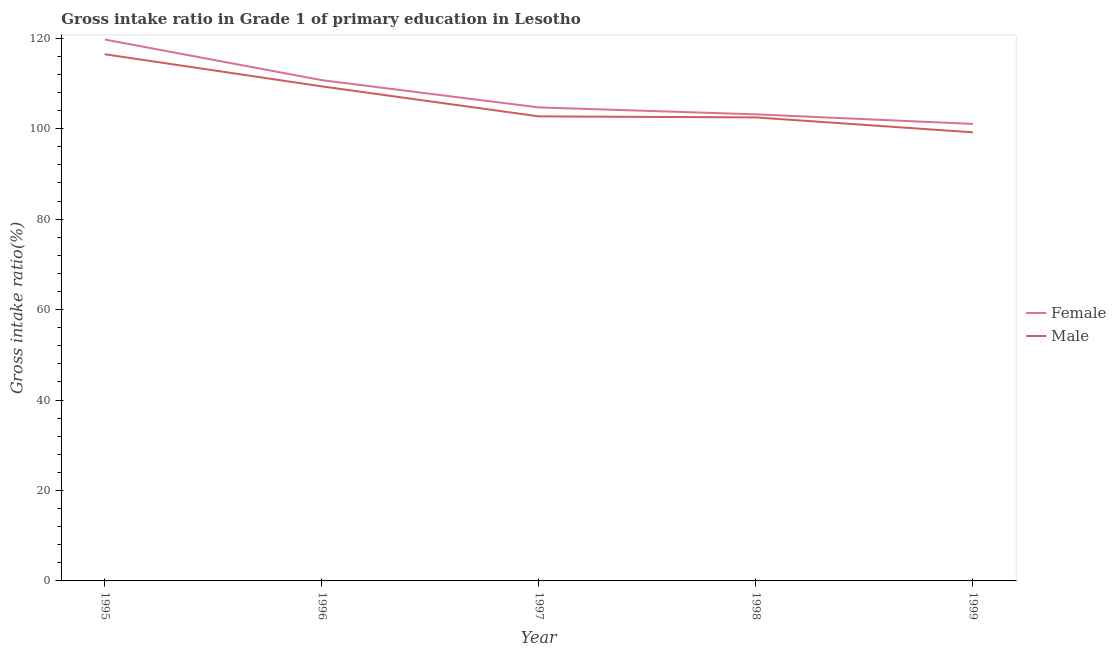How many different coloured lines are there?
Your answer should be compact. 2. Does the line corresponding to gross intake ratio(female) intersect with the line corresponding to gross intake ratio(male)?
Your answer should be compact. No. Is the number of lines equal to the number of legend labels?
Make the answer very short. Yes. What is the gross intake ratio(female) in 1997?
Make the answer very short. 104.71. Across all years, what is the maximum gross intake ratio(female)?
Give a very brief answer. 119.72. Across all years, what is the minimum gross intake ratio(male)?
Give a very brief answer. 99.2. What is the total gross intake ratio(female) in the graph?
Offer a terse response. 539.4. What is the difference between the gross intake ratio(female) in 1995 and that in 1997?
Keep it short and to the point. 15.01. What is the difference between the gross intake ratio(male) in 1996 and the gross intake ratio(female) in 1998?
Give a very brief answer. 6.19. What is the average gross intake ratio(female) per year?
Offer a very short reply. 107.88. In the year 1997, what is the difference between the gross intake ratio(female) and gross intake ratio(male)?
Your response must be concise. 1.98. What is the ratio of the gross intake ratio(male) in 1998 to that in 1999?
Your answer should be compact. 1.03. Is the gross intake ratio(male) in 1996 less than that in 1998?
Offer a terse response. No. Is the difference between the gross intake ratio(male) in 1995 and 1999 greater than the difference between the gross intake ratio(female) in 1995 and 1999?
Ensure brevity in your answer.  No. What is the difference between the highest and the second highest gross intake ratio(female)?
Your answer should be compact. 8.99. What is the difference between the highest and the lowest gross intake ratio(female)?
Provide a succinct answer. 18.67. Is the sum of the gross intake ratio(male) in 1995 and 1996 greater than the maximum gross intake ratio(female) across all years?
Offer a very short reply. Yes. Is the gross intake ratio(male) strictly greater than the gross intake ratio(female) over the years?
Offer a terse response. No. How many legend labels are there?
Your answer should be compact. 2. What is the title of the graph?
Offer a terse response. Gross intake ratio in Grade 1 of primary education in Lesotho. Does "Private consumption" appear as one of the legend labels in the graph?
Offer a terse response. No. What is the label or title of the Y-axis?
Keep it short and to the point. Gross intake ratio(%). What is the Gross intake ratio(%) of Female in 1995?
Your answer should be very brief. 119.72. What is the Gross intake ratio(%) in Male in 1995?
Your response must be concise. 116.47. What is the Gross intake ratio(%) in Female in 1996?
Your response must be concise. 110.73. What is the Gross intake ratio(%) in Male in 1996?
Your answer should be very brief. 109.36. What is the Gross intake ratio(%) of Female in 1997?
Your response must be concise. 104.71. What is the Gross intake ratio(%) in Male in 1997?
Provide a succinct answer. 102.73. What is the Gross intake ratio(%) in Female in 1998?
Your response must be concise. 103.18. What is the Gross intake ratio(%) in Male in 1998?
Provide a succinct answer. 102.5. What is the Gross intake ratio(%) of Female in 1999?
Offer a terse response. 101.06. What is the Gross intake ratio(%) of Male in 1999?
Offer a terse response. 99.2. Across all years, what is the maximum Gross intake ratio(%) in Female?
Provide a succinct answer. 119.72. Across all years, what is the maximum Gross intake ratio(%) of Male?
Your answer should be very brief. 116.47. Across all years, what is the minimum Gross intake ratio(%) in Female?
Provide a succinct answer. 101.06. Across all years, what is the minimum Gross intake ratio(%) of Male?
Offer a very short reply. 99.2. What is the total Gross intake ratio(%) of Female in the graph?
Provide a short and direct response. 539.4. What is the total Gross intake ratio(%) in Male in the graph?
Make the answer very short. 530.26. What is the difference between the Gross intake ratio(%) of Female in 1995 and that in 1996?
Offer a very short reply. 8.99. What is the difference between the Gross intake ratio(%) of Male in 1995 and that in 1996?
Offer a very short reply. 7.11. What is the difference between the Gross intake ratio(%) in Female in 1995 and that in 1997?
Ensure brevity in your answer.  15.01. What is the difference between the Gross intake ratio(%) in Male in 1995 and that in 1997?
Ensure brevity in your answer.  13.74. What is the difference between the Gross intake ratio(%) of Female in 1995 and that in 1998?
Your answer should be very brief. 16.55. What is the difference between the Gross intake ratio(%) of Male in 1995 and that in 1998?
Make the answer very short. 13.97. What is the difference between the Gross intake ratio(%) of Female in 1995 and that in 1999?
Offer a very short reply. 18.67. What is the difference between the Gross intake ratio(%) in Male in 1995 and that in 1999?
Your answer should be compact. 17.27. What is the difference between the Gross intake ratio(%) in Female in 1996 and that in 1997?
Offer a terse response. 6.02. What is the difference between the Gross intake ratio(%) in Male in 1996 and that in 1997?
Provide a short and direct response. 6.63. What is the difference between the Gross intake ratio(%) in Female in 1996 and that in 1998?
Your answer should be compact. 7.56. What is the difference between the Gross intake ratio(%) in Male in 1996 and that in 1998?
Provide a succinct answer. 6.86. What is the difference between the Gross intake ratio(%) in Female in 1996 and that in 1999?
Provide a succinct answer. 9.67. What is the difference between the Gross intake ratio(%) of Male in 1996 and that in 1999?
Offer a terse response. 10.16. What is the difference between the Gross intake ratio(%) of Female in 1997 and that in 1998?
Offer a terse response. 1.53. What is the difference between the Gross intake ratio(%) of Male in 1997 and that in 1998?
Your response must be concise. 0.23. What is the difference between the Gross intake ratio(%) in Female in 1997 and that in 1999?
Your answer should be compact. 3.65. What is the difference between the Gross intake ratio(%) of Male in 1997 and that in 1999?
Give a very brief answer. 3.53. What is the difference between the Gross intake ratio(%) of Female in 1998 and that in 1999?
Offer a very short reply. 2.12. What is the difference between the Gross intake ratio(%) of Male in 1998 and that in 1999?
Your response must be concise. 3.3. What is the difference between the Gross intake ratio(%) in Female in 1995 and the Gross intake ratio(%) in Male in 1996?
Your response must be concise. 10.36. What is the difference between the Gross intake ratio(%) in Female in 1995 and the Gross intake ratio(%) in Male in 1997?
Your answer should be very brief. 17. What is the difference between the Gross intake ratio(%) in Female in 1995 and the Gross intake ratio(%) in Male in 1998?
Your response must be concise. 17.22. What is the difference between the Gross intake ratio(%) of Female in 1995 and the Gross intake ratio(%) of Male in 1999?
Give a very brief answer. 20.52. What is the difference between the Gross intake ratio(%) in Female in 1996 and the Gross intake ratio(%) in Male in 1997?
Your answer should be very brief. 8. What is the difference between the Gross intake ratio(%) of Female in 1996 and the Gross intake ratio(%) of Male in 1998?
Keep it short and to the point. 8.23. What is the difference between the Gross intake ratio(%) of Female in 1996 and the Gross intake ratio(%) of Male in 1999?
Provide a succinct answer. 11.53. What is the difference between the Gross intake ratio(%) in Female in 1997 and the Gross intake ratio(%) in Male in 1998?
Your answer should be very brief. 2.21. What is the difference between the Gross intake ratio(%) of Female in 1997 and the Gross intake ratio(%) of Male in 1999?
Provide a short and direct response. 5.51. What is the difference between the Gross intake ratio(%) of Female in 1998 and the Gross intake ratio(%) of Male in 1999?
Provide a short and direct response. 3.98. What is the average Gross intake ratio(%) in Female per year?
Ensure brevity in your answer.  107.88. What is the average Gross intake ratio(%) of Male per year?
Provide a succinct answer. 106.05. In the year 1995, what is the difference between the Gross intake ratio(%) of Female and Gross intake ratio(%) of Male?
Ensure brevity in your answer.  3.26. In the year 1996, what is the difference between the Gross intake ratio(%) in Female and Gross intake ratio(%) in Male?
Provide a short and direct response. 1.37. In the year 1997, what is the difference between the Gross intake ratio(%) of Female and Gross intake ratio(%) of Male?
Make the answer very short. 1.98. In the year 1998, what is the difference between the Gross intake ratio(%) in Female and Gross intake ratio(%) in Male?
Offer a terse response. 0.68. In the year 1999, what is the difference between the Gross intake ratio(%) of Female and Gross intake ratio(%) of Male?
Offer a terse response. 1.86. What is the ratio of the Gross intake ratio(%) in Female in 1995 to that in 1996?
Give a very brief answer. 1.08. What is the ratio of the Gross intake ratio(%) of Male in 1995 to that in 1996?
Ensure brevity in your answer.  1.06. What is the ratio of the Gross intake ratio(%) of Female in 1995 to that in 1997?
Provide a succinct answer. 1.14. What is the ratio of the Gross intake ratio(%) in Male in 1995 to that in 1997?
Provide a succinct answer. 1.13. What is the ratio of the Gross intake ratio(%) of Female in 1995 to that in 1998?
Offer a very short reply. 1.16. What is the ratio of the Gross intake ratio(%) of Male in 1995 to that in 1998?
Ensure brevity in your answer.  1.14. What is the ratio of the Gross intake ratio(%) in Female in 1995 to that in 1999?
Keep it short and to the point. 1.18. What is the ratio of the Gross intake ratio(%) of Male in 1995 to that in 1999?
Your answer should be compact. 1.17. What is the ratio of the Gross intake ratio(%) in Female in 1996 to that in 1997?
Make the answer very short. 1.06. What is the ratio of the Gross intake ratio(%) in Male in 1996 to that in 1997?
Give a very brief answer. 1.06. What is the ratio of the Gross intake ratio(%) of Female in 1996 to that in 1998?
Your response must be concise. 1.07. What is the ratio of the Gross intake ratio(%) in Male in 1996 to that in 1998?
Ensure brevity in your answer.  1.07. What is the ratio of the Gross intake ratio(%) of Female in 1996 to that in 1999?
Provide a short and direct response. 1.1. What is the ratio of the Gross intake ratio(%) in Male in 1996 to that in 1999?
Keep it short and to the point. 1.1. What is the ratio of the Gross intake ratio(%) in Female in 1997 to that in 1998?
Your answer should be compact. 1.01. What is the ratio of the Gross intake ratio(%) in Male in 1997 to that in 1998?
Provide a succinct answer. 1. What is the ratio of the Gross intake ratio(%) in Female in 1997 to that in 1999?
Make the answer very short. 1.04. What is the ratio of the Gross intake ratio(%) of Male in 1997 to that in 1999?
Your answer should be very brief. 1.04. What is the ratio of the Gross intake ratio(%) in Female in 1998 to that in 1999?
Your answer should be compact. 1.02. What is the difference between the highest and the second highest Gross intake ratio(%) of Female?
Offer a very short reply. 8.99. What is the difference between the highest and the second highest Gross intake ratio(%) of Male?
Keep it short and to the point. 7.11. What is the difference between the highest and the lowest Gross intake ratio(%) of Female?
Your answer should be very brief. 18.67. What is the difference between the highest and the lowest Gross intake ratio(%) in Male?
Your answer should be compact. 17.27. 